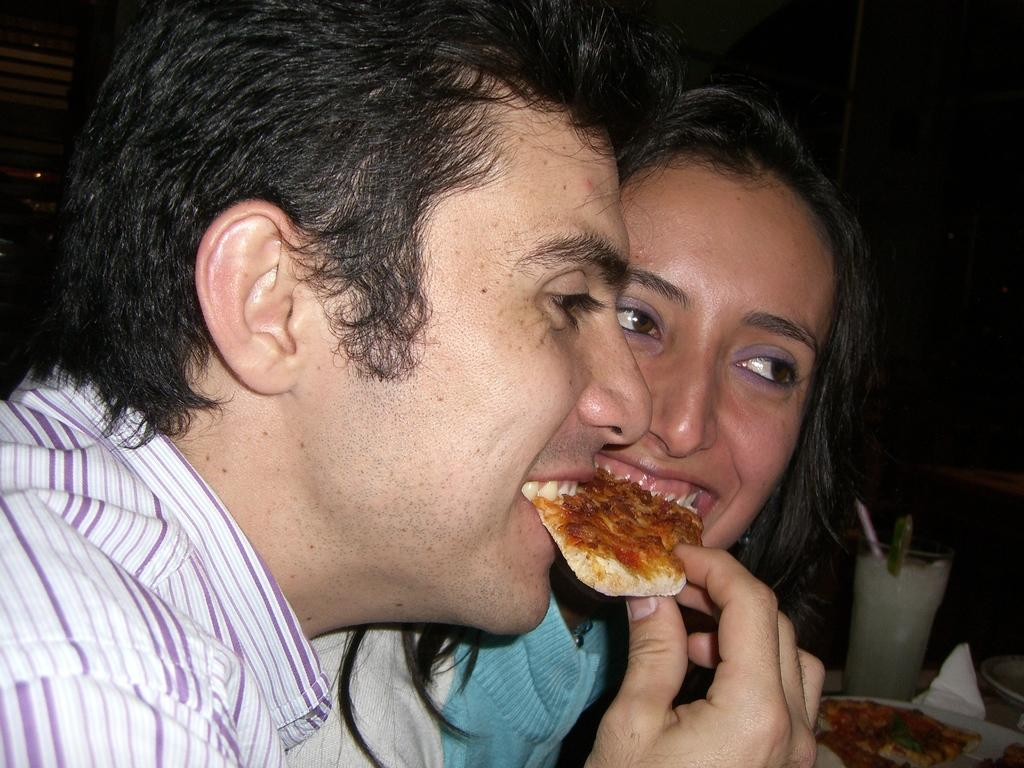What is the man in the image doing? The man is eating pizza in the image. How is the woman in the image depicted? The woman is smiling in the image. What type of furniture is present in the image? There is a dining table in the image. What items can be seen on the dining table? There is a plate and a soft drink glass on the dining table. What type of plantation can be seen in the image? There is no plantation present in the image. How does the image depict the level of pollution in the area? The image does not show any signs of pollution, and it is not possible to determine the level of pollution from the image. 